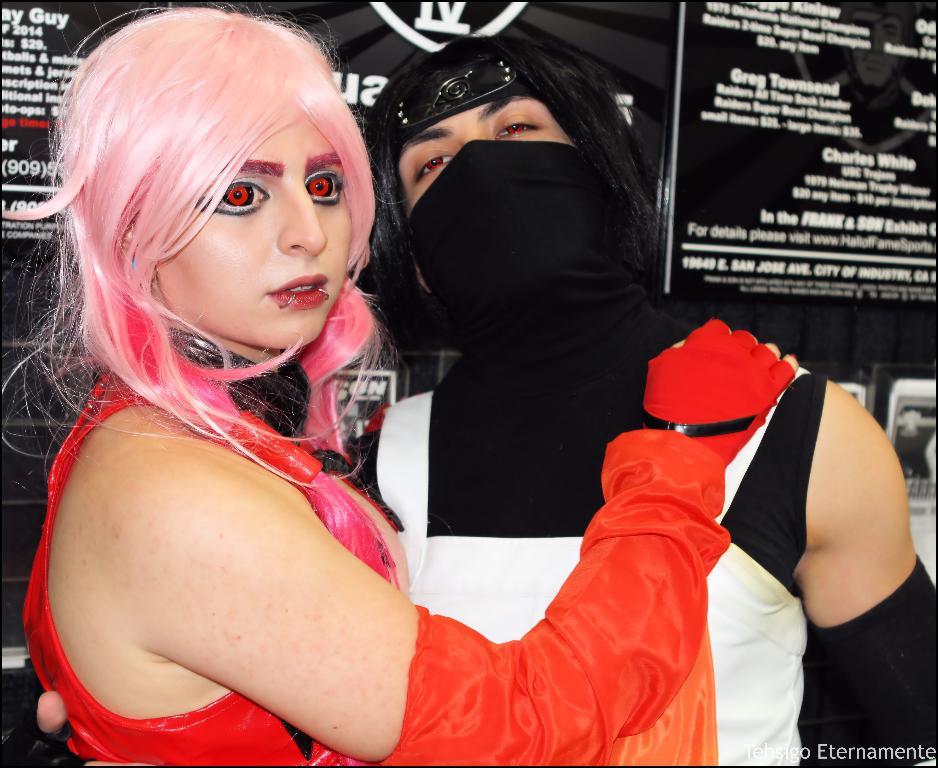Name one of the people listed on the black board?
Provide a succinct answer. Greg townsend. What word is visible at the top right?
Provide a succinct answer. Charles white. 